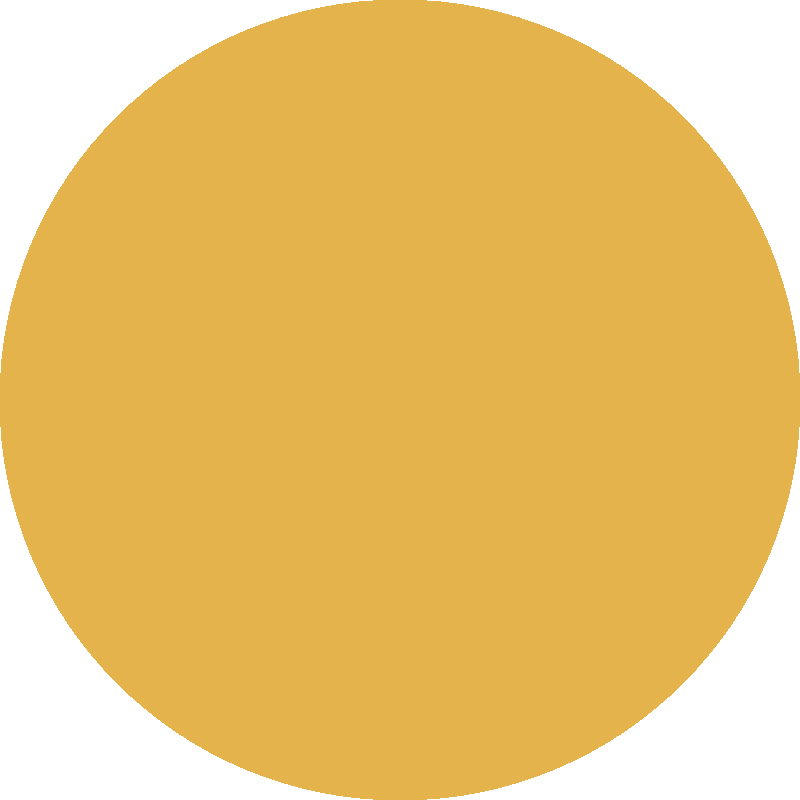Consider the traditional Norwegian rosemaling pattern shown above. What is the order of the rotational symmetry group for this pattern? To determine the order of the rotational symmetry group for this rosemaling pattern, we need to follow these steps:

1. Observe the pattern carefully: The pattern consists of 8 identical petals arranged in a circular manner.

2. Identify the symmetry operations: The pattern remains unchanged when rotated by certain angles around its center.

3. Calculate the smallest rotation angle: The smallest angle that brings the pattern back to its original position is 360° ÷ 8 = 45°.

4. Determine all possible rotations: The pattern will look the same after rotations of 45°, 90°, 135°, 180°, 225°, 270°, 315°, and 360° (which is equivalent to 0°).

5. Count the number of distinct rotations: There are 8 distinct rotations (including the identity rotation of 0°) that bring the pattern back to its original position.

6. Conclude: The order of the rotational symmetry group is equal to the number of distinct rotations, which is 8.

In group theory terms, this rotational symmetry group is isomorphic to the cyclic group $C_8$ or $\mathbb{Z}_8$.
Answer: 8 